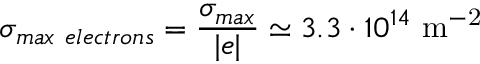<formula> <loc_0><loc_0><loc_500><loc_500>\sigma _ { \max e l e c t r o n s } = \frac { \sigma _ { \max } } { | e | } \simeq 3 . 3 \cdot 1 0 ^ { 1 4 } m ^ { - 2 }</formula> 